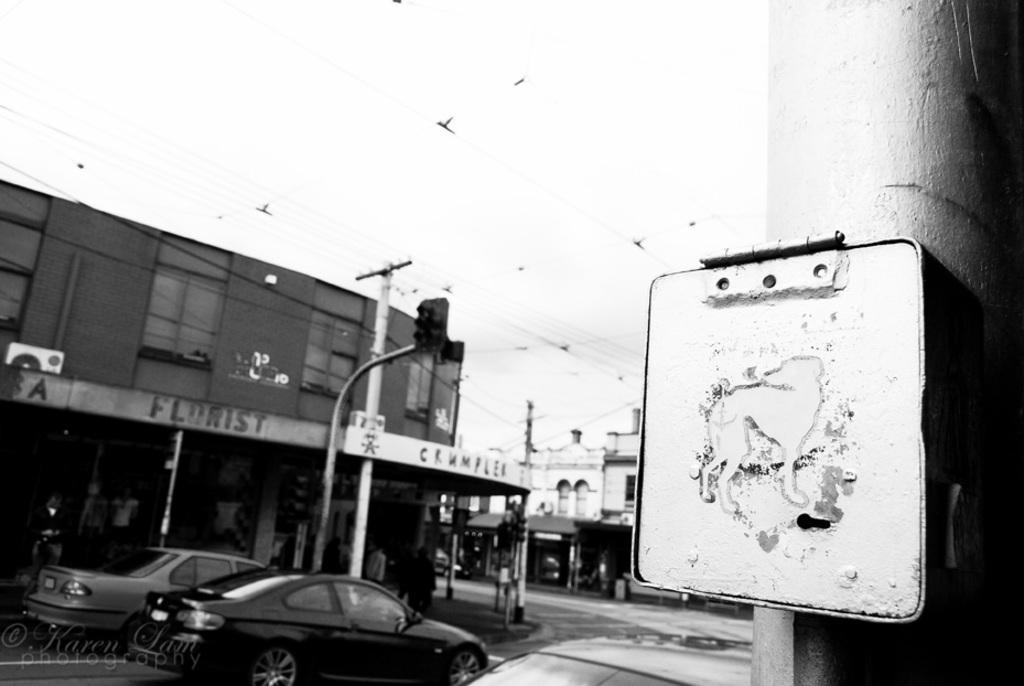Can you describe this image briefly? In this black and white image there are buildings, in front of the buildings there are a few people standing and walking and there are few vehicles on the road, utility poles connected with cables, there is a board attached to the pole. In the background there are buildings and the sky. 